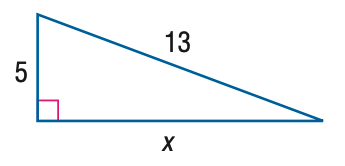Question: Find x.
Choices:
A. 9
B. 10
C. 11
D. 12
Answer with the letter. Answer: D 